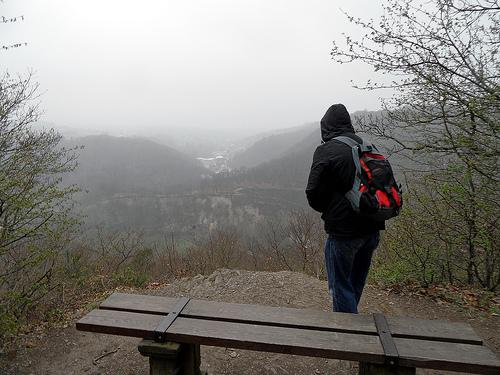Explain any apparent interaction between the person and their surroundings. The person is standing on a cliff and seems to be overlooking the valley and mountains, possibly taking in the view. Explain the scenery and weather in the image. The scenery includes mountains in the distance, a valley, a foggy sky, and trees with budding leaves. The weather appears to be cloudy. Identify the main object situated in the bottom left corner of the image. A wooden park bench with metal braces is located in the bottom left corner. Infer the emotions or sentiment conveyed by the image. The image conveys a sense of tranquility, contemplation, and appreciation for nature. List three objects or clothing items the central person possesses. The central person has a red and black backpack, a black hoodie jacket, and a pair of blue jeans. What is the central subject in the image and what are they wearing? The central subject is a person standing on a ledge, wearing a black hoodie, blue jeans, and a red and black backpack. Describe two characteristics of the red and black object carried by the person. The red and black object is a backpack, it has gray accents and is worn on the person's back. Estimate the number of trees with green buds visible in the image. There are several trees with small green buds, including at least one group of trees and multiple individual trees. What is the clothing item that the person is wearing on their head? The person is wearing a hood from their black hoodie jacket over their head. Describe the position and appearance of the bench. The bench is wooden, positioned on the left side of the image, and has metal braces on it. Describe the landscape features such as trees, water body, and sky. Group of trees with budding leaves, body of water, white hazy sky What position is the person in? Standing Do the trees have leaves, buds or are they barren? Trees have small green buds Identify the text visible in the image, if any, and provide a transcription. No text present Interpret the image as an infographic and describe its different elements. No infographic elements present Write a metaphorical description of the person's interaction with their surroundings. Like a silent guardian watching over the valley, the person stands on the cliff's edge, taking in the beauty of nature's grasp, as the fog embraces the valley below and the trees whisper the stories of the land. Is there a park bench made of glass in the image? The image contains a wooden park bench, not a glass one. The instruction is misleading as it implies the existence of a glass park bench in the image. Describe the hoodie jacket worn by the person. Black hoodie jacket Describe the type of day depicted in the image. Cloudy and foggy Identify any significant event happening in the image. Person looking out at mountains from a cliff Is the person standing on a ledge, wearing jeans? Provide a Yes or No response. Yes Are there tall buildings visible in the town in the distance? The image mentions a town in the distance, but there is no specific information about tall buildings. The instruction falsely suggests that tall buildings are a distinguishing feature of the town depicted in the image. Do you see an orange and blue backpack on the person? The image contains a red and black backpack, not an orange and blue one. The instruction is misleading as it falsely implies that the backpack has different colors than what is actually shown. What is the person in the image doing? Standing on a ledge, overlooking a view Are there purple flowers growing around the trees? There is no mention of purple flowers in the image. The instruction is misleading as it implies the presence of flowers that aren't actually there. Provide a detailed description of the bench. Wooden park bench with metal straps, possibly with a metal brace Identify numbers visible in the image and transcribe them. No numbers visible Describe the person's facial features, if visible. Facial features are not visible Create a short story inspired by the scene captured in the image. On a foggy day, overcome by wanderlust, a young adventurer stands on a cliff overlooking a breathtaking valley. They wear a red and black backpack, black hoodie, and blue jeans as they take in the breathtaking view. A wooden bench nearby rests silently, observing. The sky, although covered with a white haze, conveys a sense of serenity. Trees with small green buds sit atop the quietly roaring mountains in the distance. Is there any significant event taking place involving the trees? No significant event involving trees What color is the backpack and can you describe in detail any design elements that might be present? Red and black, with gray elements Is the body of water frozen and covered in ice? The image has a body of water, but there is no information about it being frozen or covered in ice. The instruction is misleading as it implies that the body of water has different attributes than what is provided. What material is the park bench made of? Wooden Can you see a person wearing a green hat on the ledge? The image contains a person standing on the ledge, but there is no information about them wearing a green hat. The instruction is misleading as it suggests an additional accessory not present in the image. Analyze the image as if it were a diagram and describe its components. No diagram present in the image 